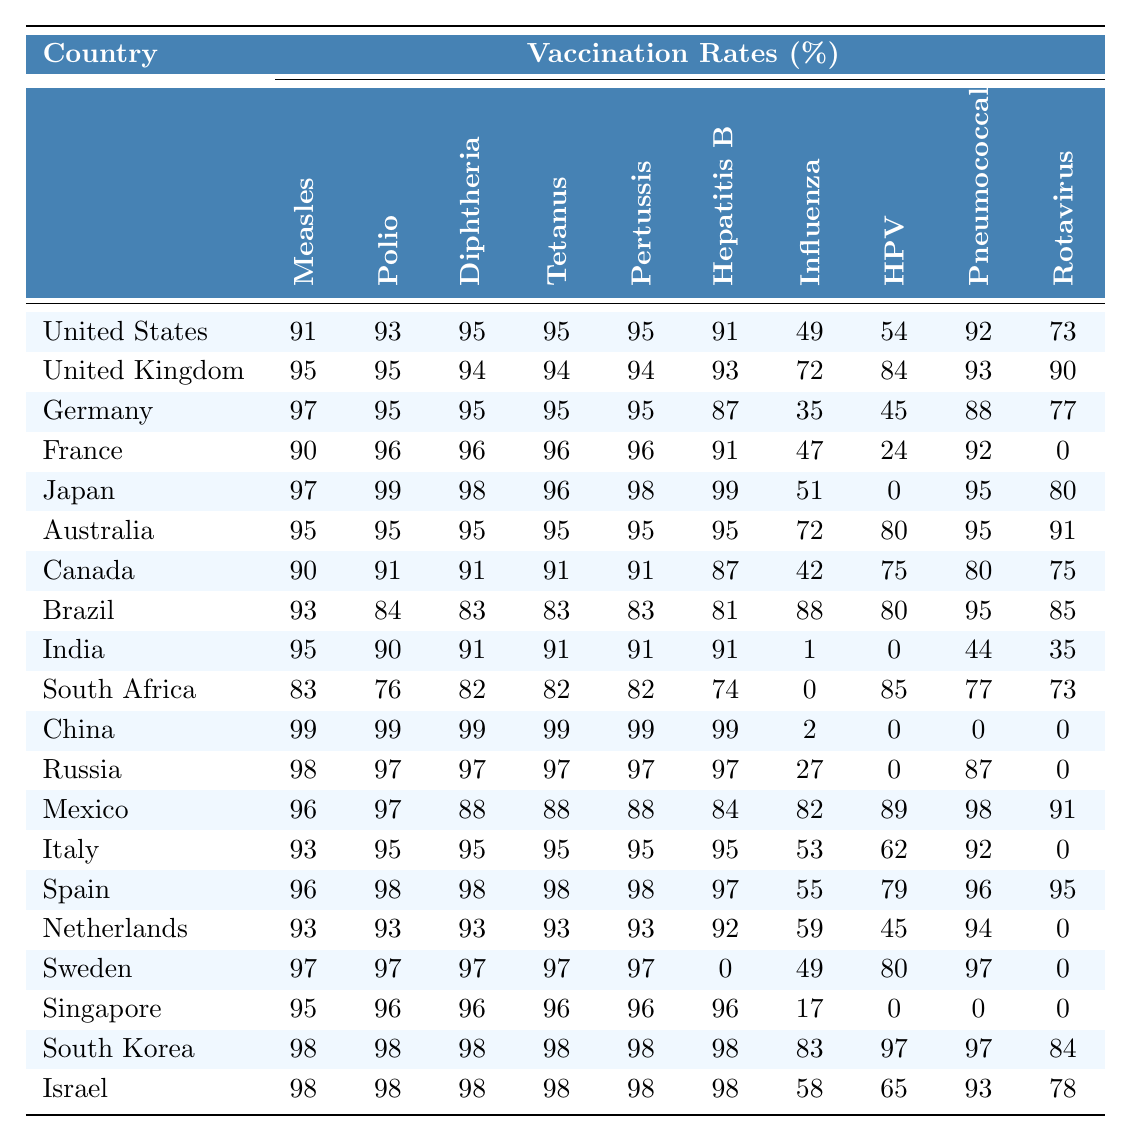What is the vaccination rate for measles in Japan? Referring directly to the table, the vaccination rate for measles in Japan is listed as 97%.
Answer: 97% Which country has the highest polio vaccination rate? Looking through the table, China and Japan both have the highest polio vaccination rate of 99%.
Answer: China and Japan What is the difference in the vaccination rates for Diphtheria between the United States and Australia? For the United States, the Diphtheria vaccination rate is 95%, while for Australia, it is also 95%. The difference is 95 - 95 = 0%.
Answer: 0% Does South Africa have a higher or lower vaccination rate for Rotavirus compared to Canada? South Africa has a Rotavirus vaccination rate of 73%, while Canada has a rate of 75%. Since 75% is greater than 73%, Canada has a higher vaccination rate for Rotavirus.
Answer: Lower What is the average vaccination rate for HPV across all countries listed? To find the average for HPV, we sum up all the HPV rates: 54 + 84 + 45 + 24 + 0 + 80 + 75 + 80 + 0 + 85 + 0 + 0 + 89 + 62 + 79 + 45 + 80 + 0 + 97 + 65 = 783. There are 20 countries, so the average is 783 / 20 = 39.15%.
Answer: 39.15% Which two countries have the lowest vaccination rates for Influenza? The table shows that India has an Influenza vaccination rate of 1%, and China has 2%. Thus, India has the lowest rate, followed by China.
Answer: India and China Are there any countries with a 0% vaccination rate for HPV? By inspecting the table, we can see that both Japan and China have a 0% vaccination rate for HPV.
Answer: Yes What is the ratio of the Pneumococcal vaccination rates between China and the United States? The Pneumococcal vaccination rate for China is 0%, and for the United States, it is 92%. Since you cannot divide by zero, the ratio is undefined.
Answer: Undefined Rank the top three countries by their vaccination rate for Pertussis. The table shows Japan, China, and South Korea having the highest rates for Pertussis at 98%. The ranking is Japan, China, and South Korea.
Answer: Japan, China, South Korea What is the combined vaccination rate for Hepatitis B in Brazil and India? Brazil's vaccination rate for Hepatitis B is 81%, while India's rate is 91%. The combined score is 81 + 91 = 172%.
Answer: 172% Is the average vaccination rate for measles in European countries higher than 95%? The average measles vaccination rate for the European countries (United Kingdom, Germany, France, Italy, Spain, Netherlands, Sweden) can be calculated as follows: (95 + 97 + 90 + 93 + 96 + 93 + 97) / 7 = 94.14%. Since 94.14% is lower than 95%, the answer is no.
Answer: No 